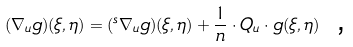Convert formula to latex. <formula><loc_0><loc_0><loc_500><loc_500>( \nabla _ { u } g ) ( \xi , \eta ) = ( ^ { s } \nabla _ { u } g ) ( \xi , \eta ) + \frac { 1 } { n } \cdot Q _ { u } \cdot g ( \xi , \eta ) \text { ,}</formula> 